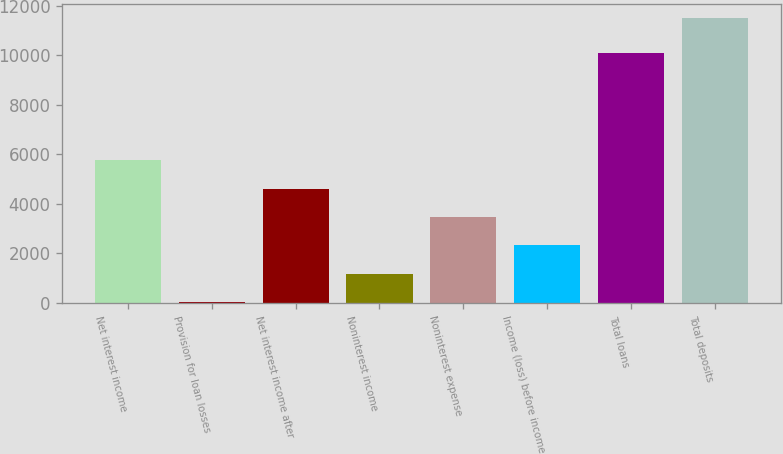Convert chart to OTSL. <chart><loc_0><loc_0><loc_500><loc_500><bar_chart><fcel>Net interest income<fcel>Provision for loan losses<fcel>Net interest income after<fcel>Noninterest income<fcel>Noninterest expense<fcel>Income (loss) before income<fcel>Total loans<fcel>Total deposits<nl><fcel>5761.6<fcel>32.2<fcel>4615.72<fcel>1178.08<fcel>3469.84<fcel>2323.96<fcel>10077<fcel>11491<nl></chart> 